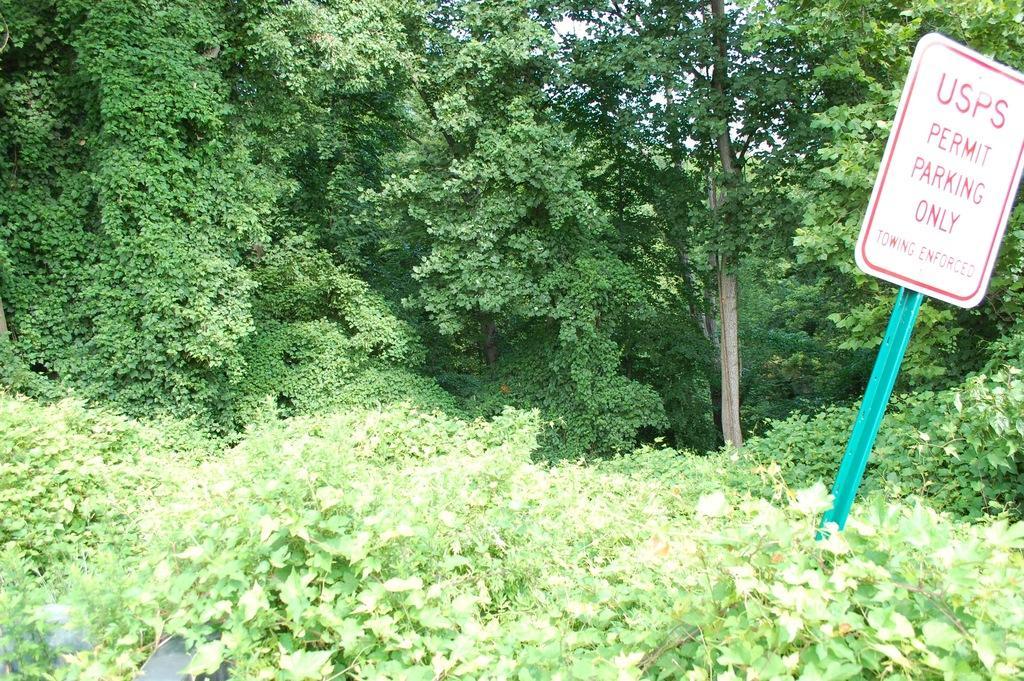Can you describe this image briefly? In this picture there are trees and there are plants. On the right side there is a board with some text written on it. 